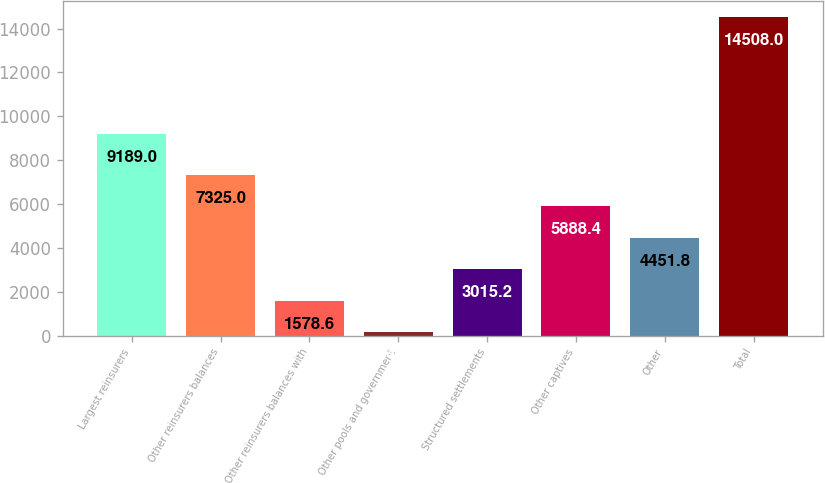<chart> <loc_0><loc_0><loc_500><loc_500><bar_chart><fcel>Largest reinsurers<fcel>Other reinsurers balances<fcel>Other reinsurers balances with<fcel>Other pools and government<fcel>Structured settlements<fcel>Other captives<fcel>Other<fcel>Total<nl><fcel>9189<fcel>7325<fcel>1578.6<fcel>142<fcel>3015.2<fcel>5888.4<fcel>4451.8<fcel>14508<nl></chart> 